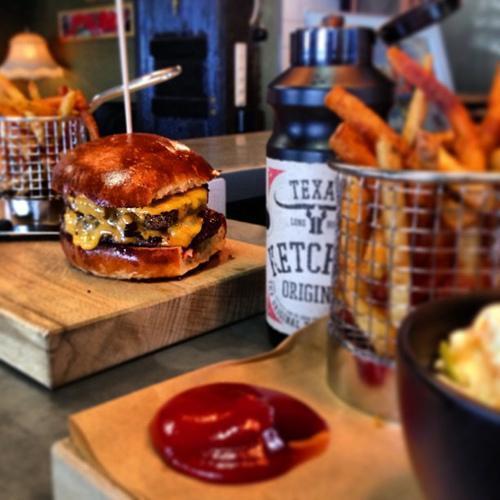How many meals?
Give a very brief answer. 1. 